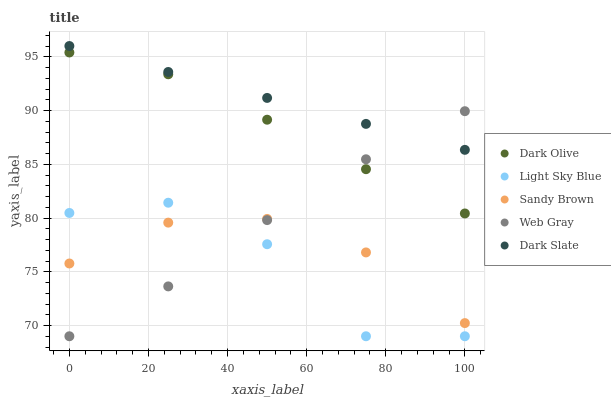Does Light Sky Blue have the minimum area under the curve?
Answer yes or no. Yes. Does Dark Slate have the maximum area under the curve?
Answer yes or no. Yes. Does Dark Olive have the minimum area under the curve?
Answer yes or no. No. Does Dark Olive have the maximum area under the curve?
Answer yes or no. No. Is Dark Slate the smoothest?
Answer yes or no. Yes. Is Light Sky Blue the roughest?
Answer yes or no. Yes. Is Dark Olive the smoothest?
Answer yes or no. No. Is Dark Olive the roughest?
Answer yes or no. No. Does Web Gray have the lowest value?
Answer yes or no. Yes. Does Dark Olive have the lowest value?
Answer yes or no. No. Does Dark Slate have the highest value?
Answer yes or no. Yes. Does Dark Olive have the highest value?
Answer yes or no. No. Is Light Sky Blue less than Dark Slate?
Answer yes or no. Yes. Is Dark Olive greater than Light Sky Blue?
Answer yes or no. Yes. Does Light Sky Blue intersect Web Gray?
Answer yes or no. Yes. Is Light Sky Blue less than Web Gray?
Answer yes or no. No. Is Light Sky Blue greater than Web Gray?
Answer yes or no. No. Does Light Sky Blue intersect Dark Slate?
Answer yes or no. No. 